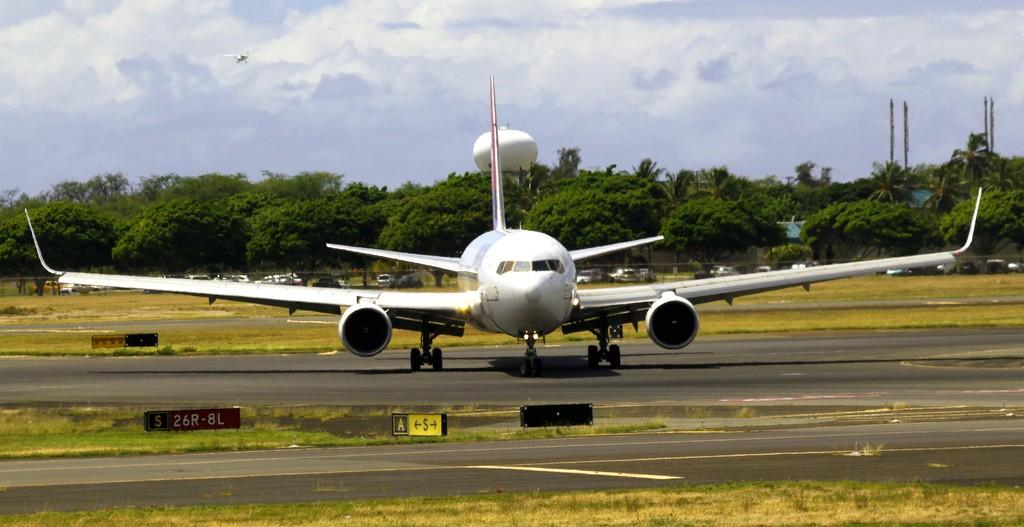<image>
Relay a brief, clear account of the picture shown. a plane is heading toward the sign pointing to lanes A and S 